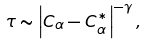Convert formula to latex. <formula><loc_0><loc_0><loc_500><loc_500>\tau \sim \left | C _ { \alpha } - C _ { \alpha } ^ { * } \right | ^ { - \gamma } ,</formula> 